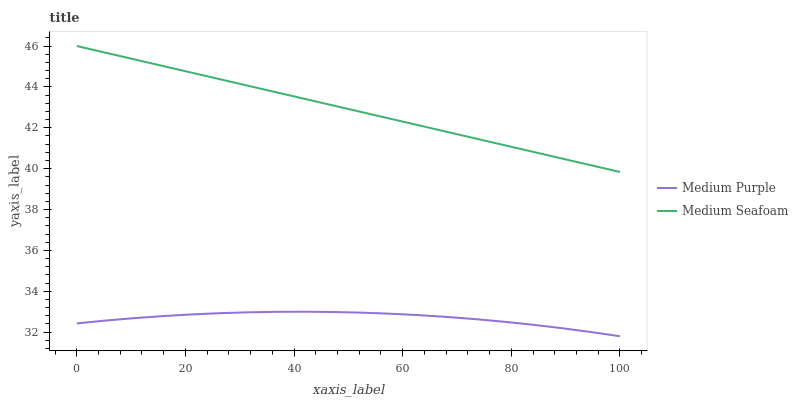Does Medium Seafoam have the minimum area under the curve?
Answer yes or no. No. Is Medium Seafoam the roughest?
Answer yes or no. No. Does Medium Seafoam have the lowest value?
Answer yes or no. No. Is Medium Purple less than Medium Seafoam?
Answer yes or no. Yes. Is Medium Seafoam greater than Medium Purple?
Answer yes or no. Yes. Does Medium Purple intersect Medium Seafoam?
Answer yes or no. No. 